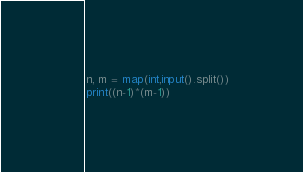Convert code to text. <code><loc_0><loc_0><loc_500><loc_500><_Python_>n, m = map(int,input().split())
print((n-1)*(m-1))</code> 